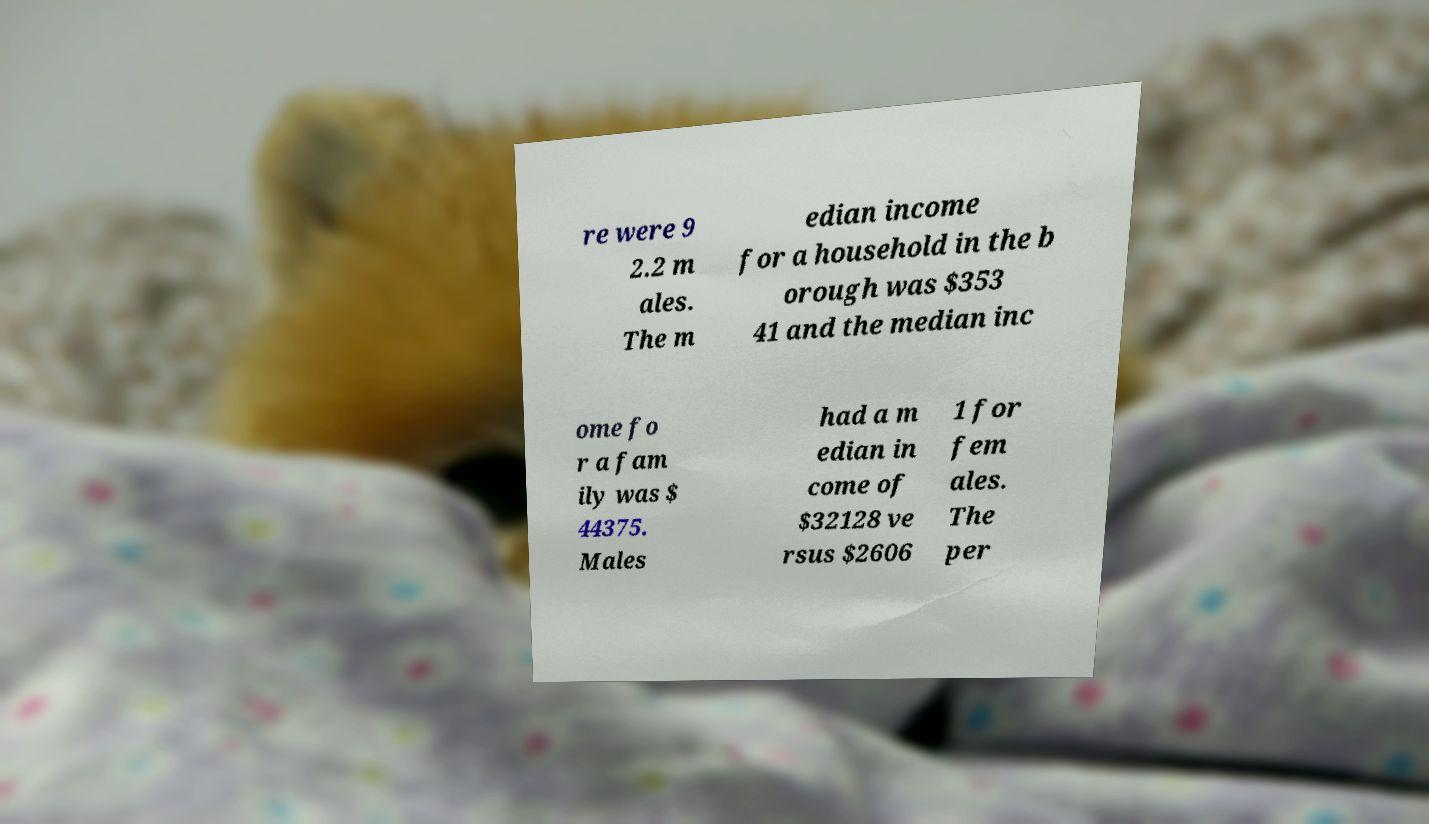For documentation purposes, I need the text within this image transcribed. Could you provide that? re were 9 2.2 m ales. The m edian income for a household in the b orough was $353 41 and the median inc ome fo r a fam ily was $ 44375. Males had a m edian in come of $32128 ve rsus $2606 1 for fem ales. The per 